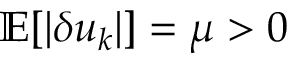<formula> <loc_0><loc_0><loc_500><loc_500>\mathbb { E } [ | \delta u _ { k } | ] = \mu > 0</formula> 